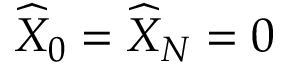Convert formula to latex. <formula><loc_0><loc_0><loc_500><loc_500>\widehat { X } _ { 0 } = \widehat { X } _ { N } = 0</formula> 